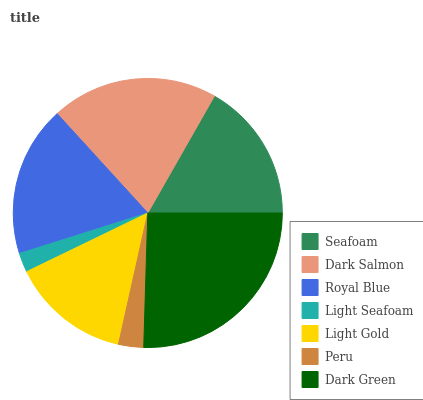Is Light Seafoam the minimum?
Answer yes or no. Yes. Is Dark Green the maximum?
Answer yes or no. Yes. Is Dark Salmon the minimum?
Answer yes or no. No. Is Dark Salmon the maximum?
Answer yes or no. No. Is Dark Salmon greater than Seafoam?
Answer yes or no. Yes. Is Seafoam less than Dark Salmon?
Answer yes or no. Yes. Is Seafoam greater than Dark Salmon?
Answer yes or no. No. Is Dark Salmon less than Seafoam?
Answer yes or no. No. Is Seafoam the high median?
Answer yes or no. Yes. Is Seafoam the low median?
Answer yes or no. Yes. Is Light Gold the high median?
Answer yes or no. No. Is Light Seafoam the low median?
Answer yes or no. No. 